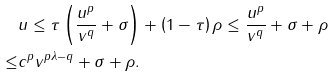<formula> <loc_0><loc_0><loc_500><loc_500>& u \leq \tau \left ( \frac { u ^ { p } } { v ^ { q } } + \sigma \right ) + \left ( 1 - \tau \right ) \rho \leq \frac { u ^ { p } } { v ^ { q } } + \sigma + \rho \\ \leq & c ^ { p } v ^ { p \lambda - q } + \sigma + \rho .</formula> 